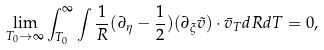Convert formula to latex. <formula><loc_0><loc_0><loc_500><loc_500>\lim _ { T _ { 0 } \rightarrow \infty } \int _ { T _ { 0 } } ^ { \infty } \int \frac { 1 } { R } ( \partial _ { \eta } - \frac { 1 } { 2 } ) ( \partial _ { \xi } \tilde { v } ) \cdot \bar { v } _ { T } d R d T = 0 ,</formula> 